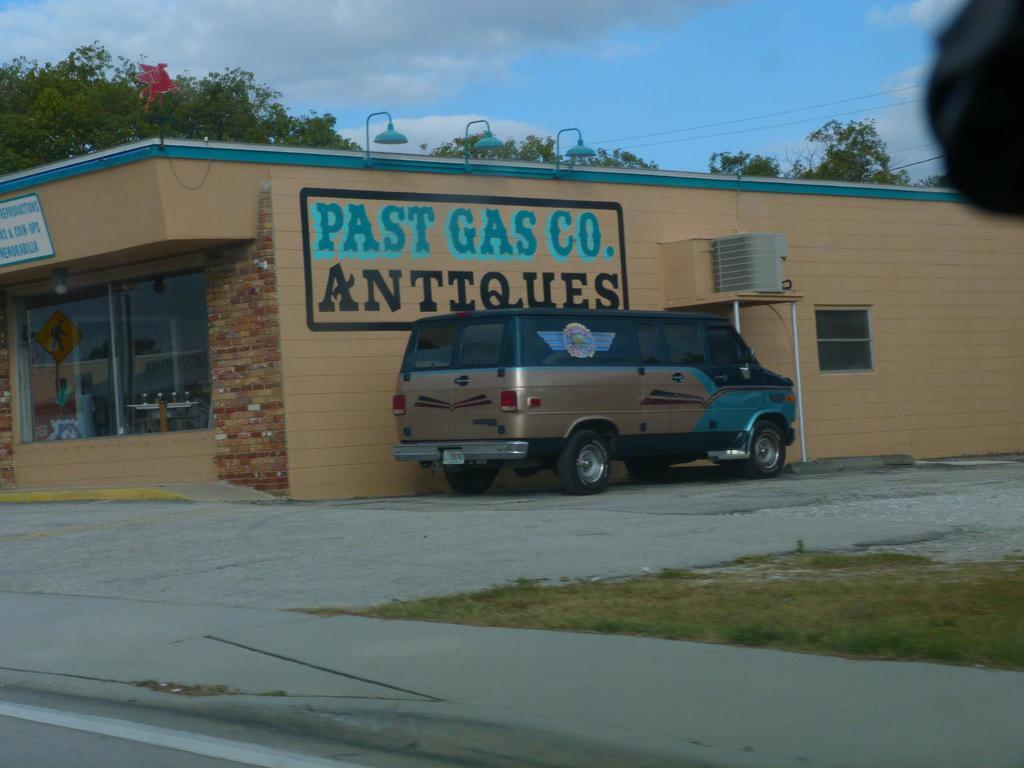<image>
Relay a brief, clear account of the picture shown. A building that has Pasta Gas Co. on it 